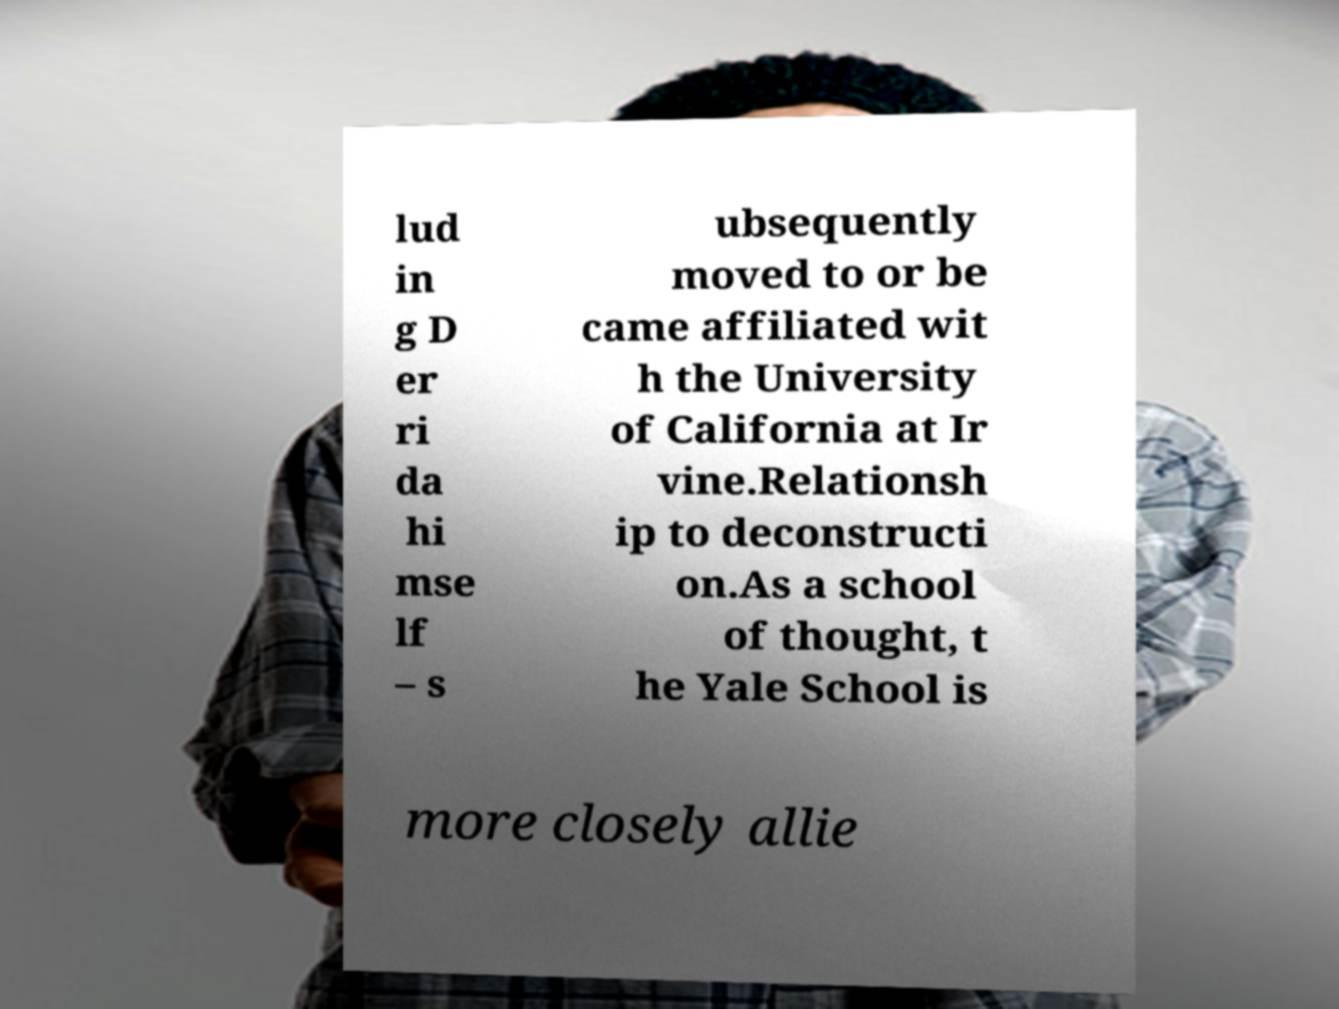I need the written content from this picture converted into text. Can you do that? lud in g D er ri da hi mse lf – s ubsequently moved to or be came affiliated wit h the University of California at Ir vine.Relationsh ip to deconstructi on.As a school of thought, t he Yale School is more closely allie 